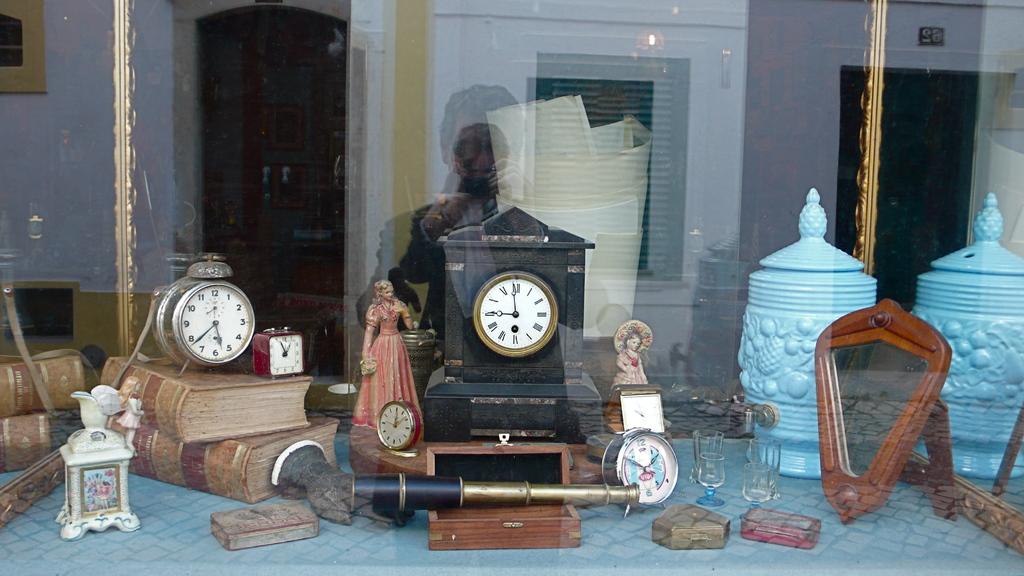What time does the black clock read?
Your answer should be very brief. 9:00. What time is on the round clock on the left?
Your answer should be compact. 5:40. 